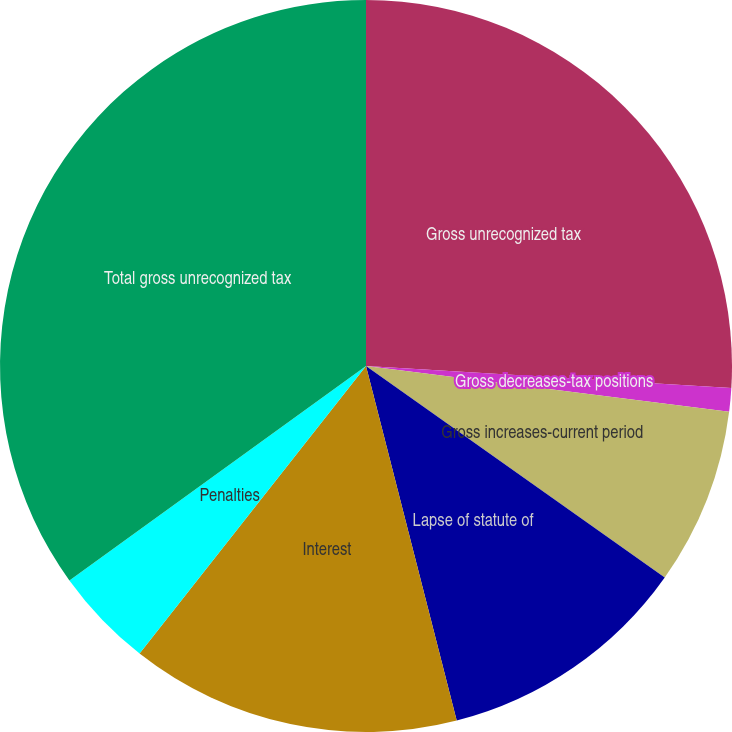Convert chart to OTSL. <chart><loc_0><loc_0><loc_500><loc_500><pie_chart><fcel>Gross unrecognized tax<fcel>Gross decreases-tax positions<fcel>Gross increases-current period<fcel>Lapse of statute of<fcel>Interest<fcel>Penalties<fcel>Total gross unrecognized tax<nl><fcel>25.96%<fcel>1.03%<fcel>7.81%<fcel>11.21%<fcel>14.6%<fcel>4.42%<fcel>34.96%<nl></chart> 